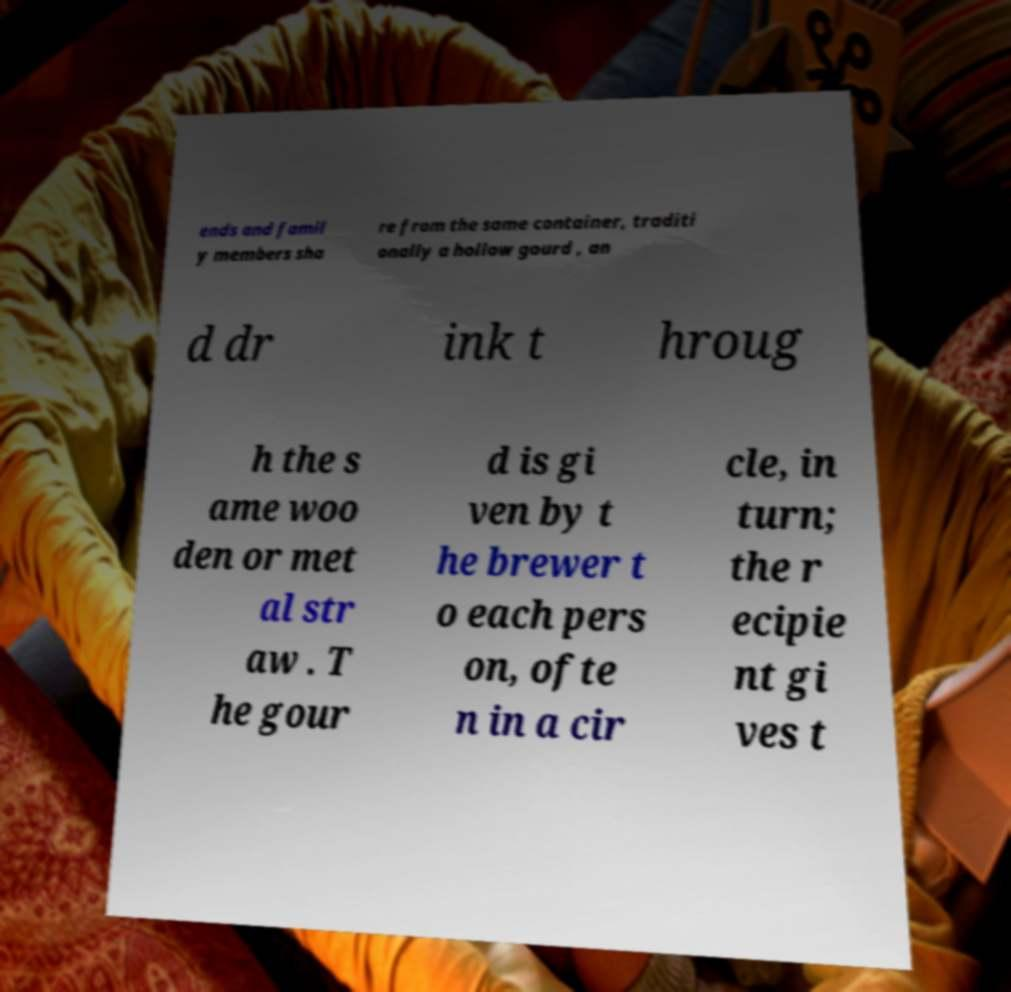I need the written content from this picture converted into text. Can you do that? ends and famil y members sha re from the same container, traditi onally a hollow gourd , an d dr ink t hroug h the s ame woo den or met al str aw . T he gour d is gi ven by t he brewer t o each pers on, ofte n in a cir cle, in turn; the r ecipie nt gi ves t 